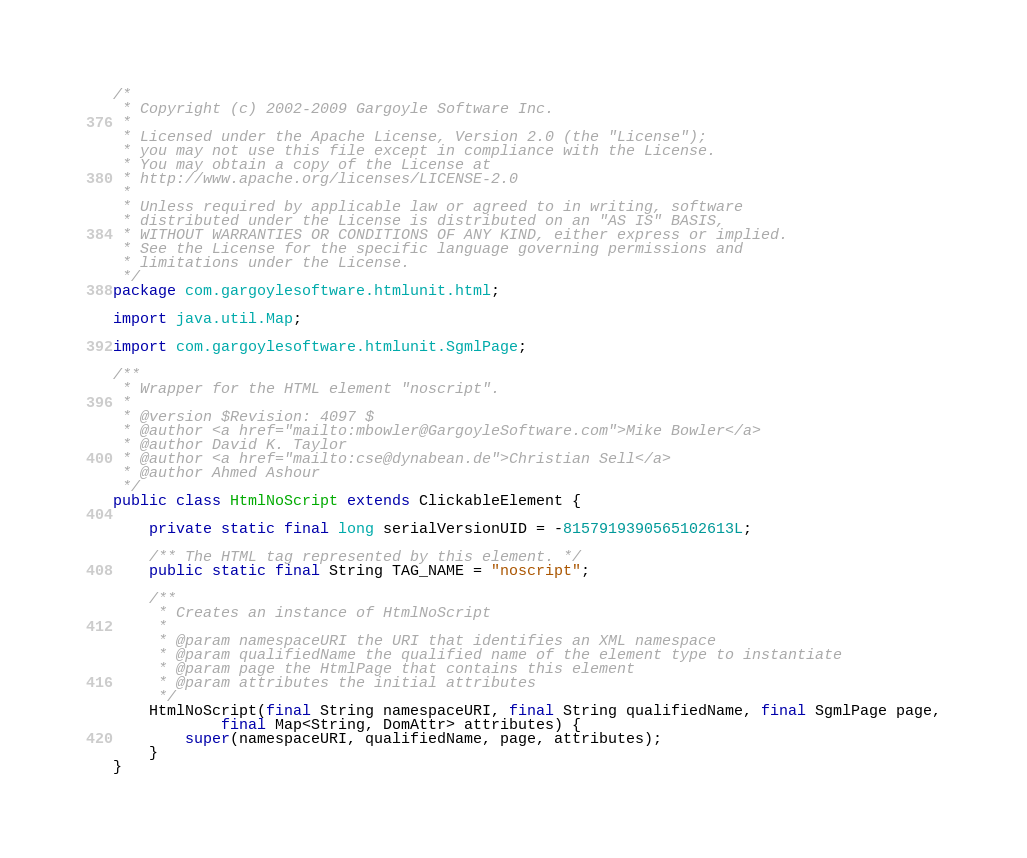Convert code to text. <code><loc_0><loc_0><loc_500><loc_500><_Java_>/*
 * Copyright (c) 2002-2009 Gargoyle Software Inc.
 *
 * Licensed under the Apache License, Version 2.0 (the "License");
 * you may not use this file except in compliance with the License.
 * You may obtain a copy of the License at
 * http://www.apache.org/licenses/LICENSE-2.0
 *
 * Unless required by applicable law or agreed to in writing, software
 * distributed under the License is distributed on an "AS IS" BASIS,
 * WITHOUT WARRANTIES OR CONDITIONS OF ANY KIND, either express or implied.
 * See the License for the specific language governing permissions and
 * limitations under the License.
 */
package com.gargoylesoftware.htmlunit.html;

import java.util.Map;

import com.gargoylesoftware.htmlunit.SgmlPage;

/**
 * Wrapper for the HTML element "noscript".
 *
 * @version $Revision: 4097 $
 * @author <a href="mailto:mbowler@GargoyleSoftware.com">Mike Bowler</a>
 * @author David K. Taylor
 * @author <a href="mailto:cse@dynabean.de">Christian Sell</a>
 * @author Ahmed Ashour
 */
public class HtmlNoScript extends ClickableElement {

    private static final long serialVersionUID = -8157919390565102613L;

    /** The HTML tag represented by this element. */
    public static final String TAG_NAME = "noscript";

    /**
     * Creates an instance of HtmlNoScript
     *
     * @param namespaceURI the URI that identifies an XML namespace
     * @param qualifiedName the qualified name of the element type to instantiate
     * @param page the HtmlPage that contains this element
     * @param attributes the initial attributes
     */
    HtmlNoScript(final String namespaceURI, final String qualifiedName, final SgmlPage page,
            final Map<String, DomAttr> attributes) {
        super(namespaceURI, qualifiedName, page, attributes);
    }
}
</code> 